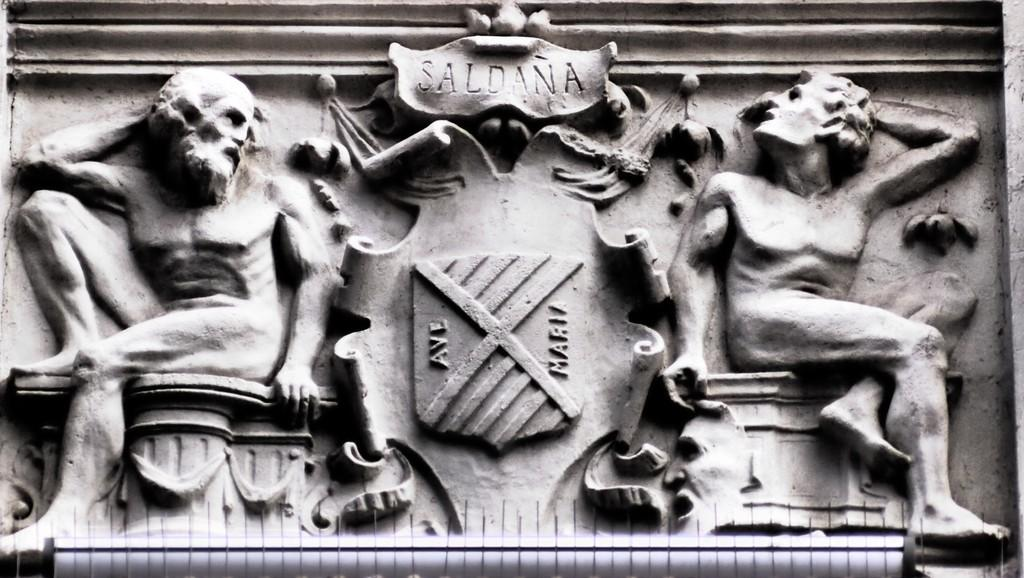<image>
Create a compact narrative representing the image presented. stone engraved figures of two old men with Ave Maria words on middle shield and Saldana on top 